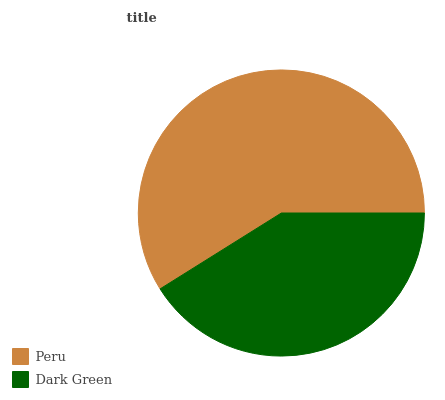Is Dark Green the minimum?
Answer yes or no. Yes. Is Peru the maximum?
Answer yes or no. Yes. Is Dark Green the maximum?
Answer yes or no. No. Is Peru greater than Dark Green?
Answer yes or no. Yes. Is Dark Green less than Peru?
Answer yes or no. Yes. Is Dark Green greater than Peru?
Answer yes or no. No. Is Peru less than Dark Green?
Answer yes or no. No. Is Peru the high median?
Answer yes or no. Yes. Is Dark Green the low median?
Answer yes or no. Yes. Is Dark Green the high median?
Answer yes or no. No. Is Peru the low median?
Answer yes or no. No. 